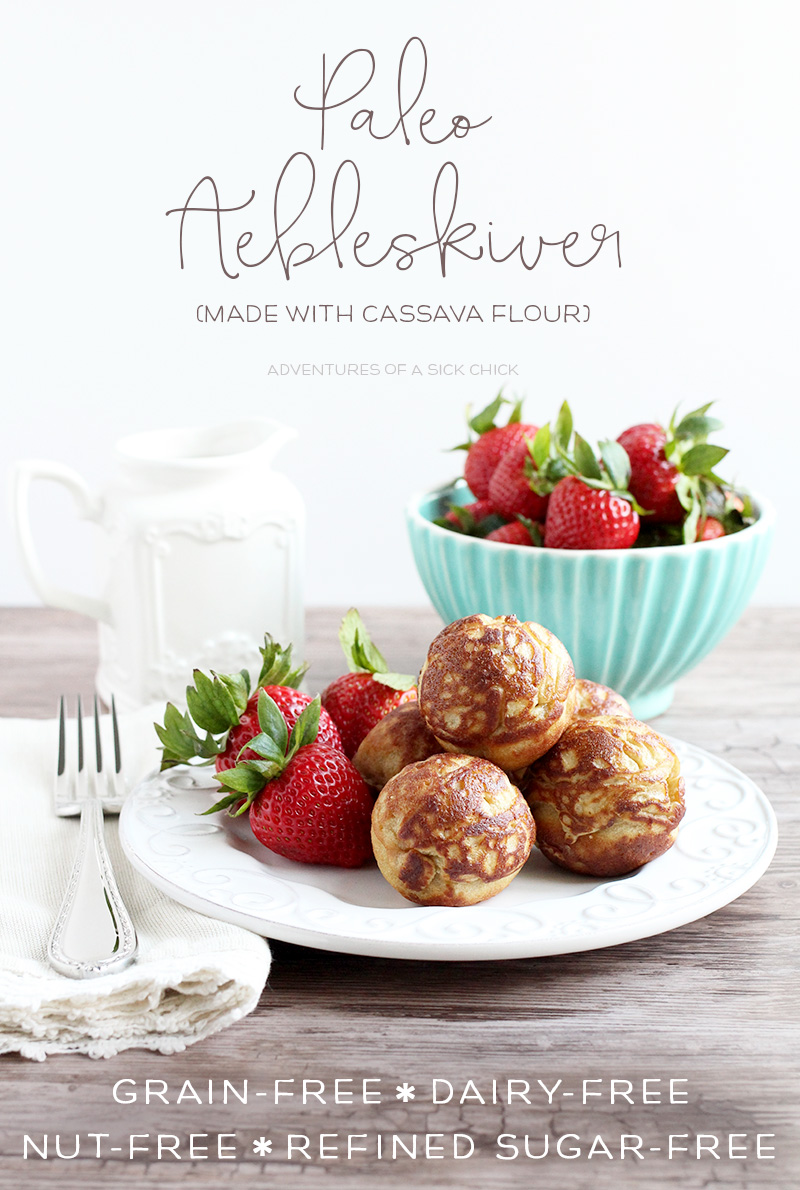What are some potential health benefits of using cassava flour in baking? Cassava flour offers several health benefits when used in baking. Firstly, it is gluten-free, which makes it a safe option for those with celiac disease or gluten intolerance. It is also grain-free, making it ideal for those on a Paleo diet or anyone avoiding grains. Cassava flour is rich in resistant starch, a type of carbohydrate that feeds the beneficial bacteria in the gut, improving digestive health and supporting a healthy microbiome. Additionally, it is free from nuts and dairy, making it suitable for individuals with allergies to these food groups. The flour is also relatively low in sugar and calories compared to traditional wheat flour, which can help with weight management. Overall, using cassava flour can contribute to a healthier digestive system, better management of food allergies, and support for a grain-free dietary lifestyle. How can cassava flour impact the texture and taste of baked goods compared to wheat flour? Cassava flour is known for its neutral flavor, which allows it to blend seamlessly into both sweet and savory baked goods without altering the intended taste. In terms of texture, cassava flour can closely mimic the properties of wheat flour, providing a light and fluffy consistency when properly used in recipes. However, it is essential to note that cassava flour absorbs more liquid than wheat flour, so adjustments in recipes might be necessary to achieve the desired texture. When used in pastries like the æbleskiver featured in the image, cassava flour ensures they remain soft on the inside while obtaining a crispy exterior, similar to their wheat-based counterparts. This makes cassava flour a versatile and excellent choice for various baking applications. 